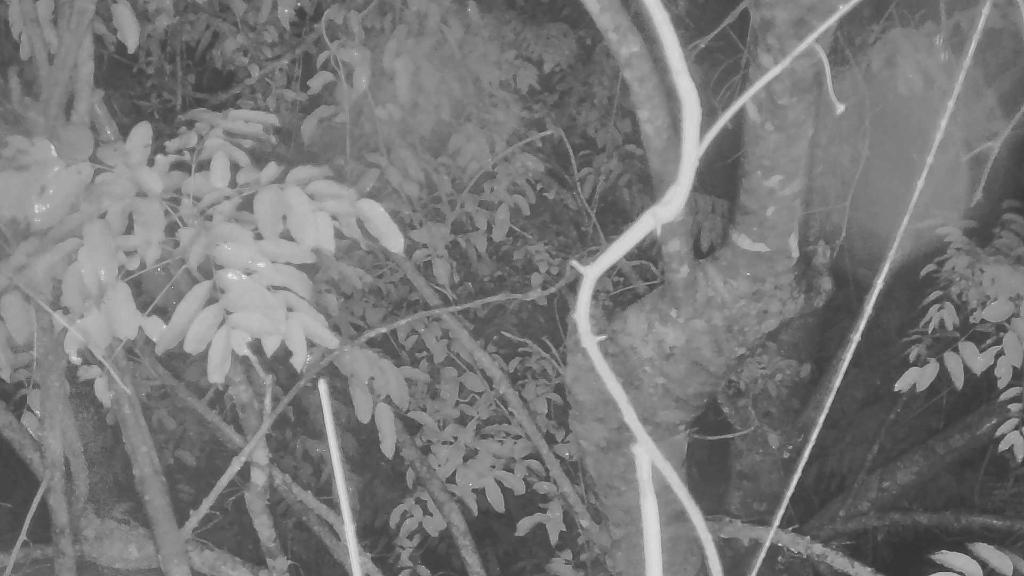Please provide a concise description of this image. This is a black and white image. In this image we can see branches of trees with leaves. 